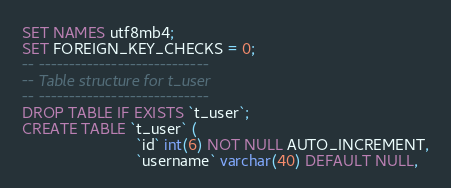<code> <loc_0><loc_0><loc_500><loc_500><_SQL_>SET NAMES utf8mb4;
SET FOREIGN_KEY_CHECKS = 0;
-- ----------------------------
-- Table structure for t_user
-- ----------------------------
DROP TABLE IF EXISTS `t_user`;
CREATE TABLE `t_user` (
                          `id` int(6) NOT NULL AUTO_INCREMENT,
                          `username` varchar(40) DEFAULT NULL,</code> 